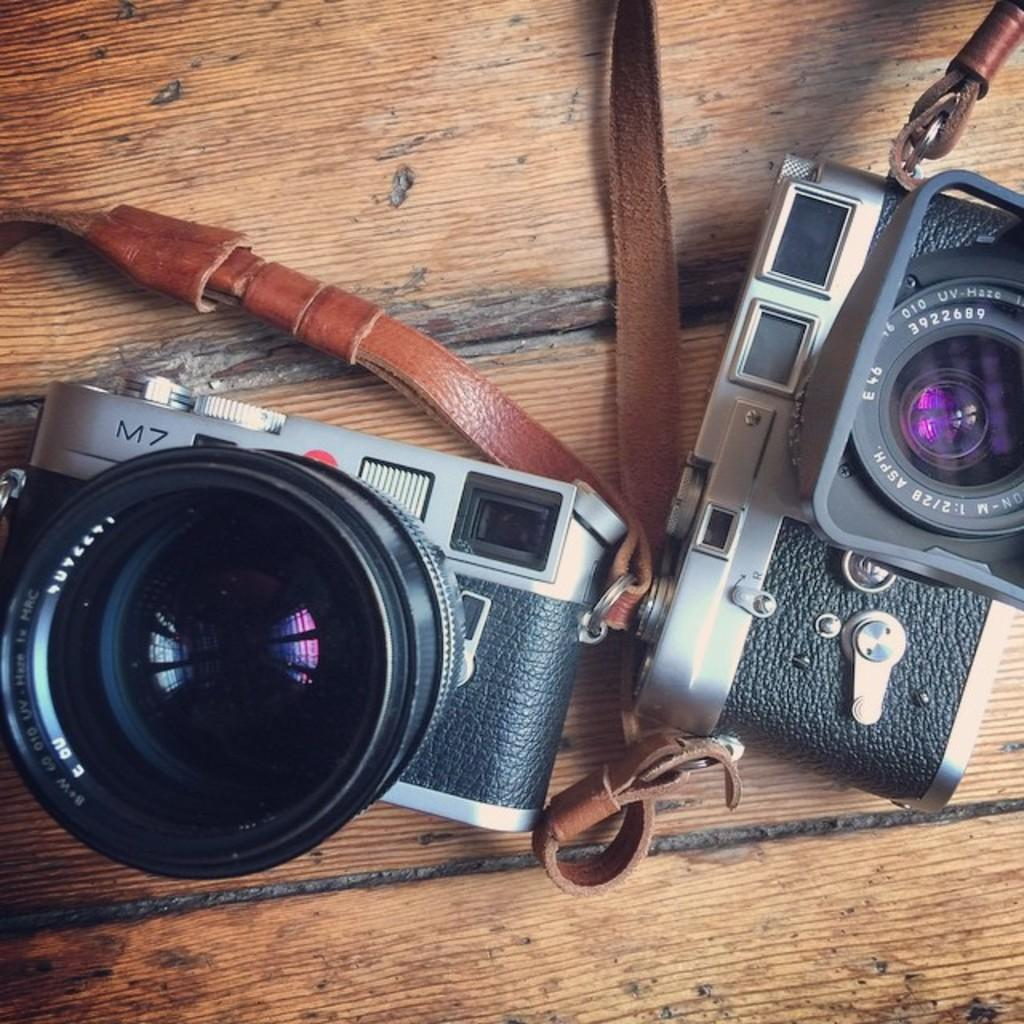What objects are present in the image? There are cameras in the image. What is the surface on which the cameras are placed? The cameras are placed on a wooden surface. Are there any bears attacking the cameras in the image? No, there are no bears or attacks present in the image; it only features cameras placed on a wooden surface. 